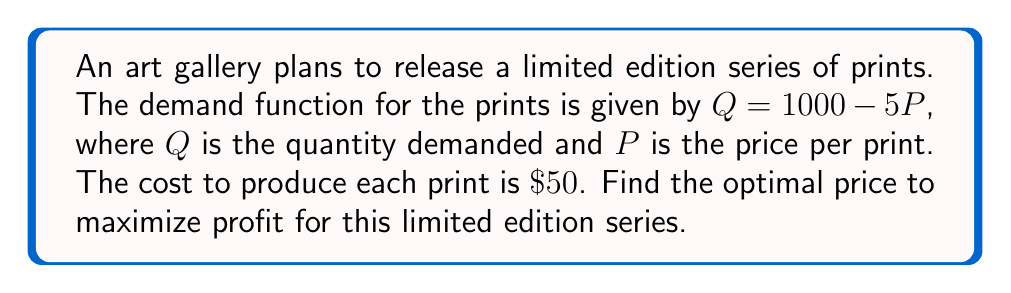Give your solution to this math problem. Let's approach this step-by-step:

1) First, we need to set up the profit function. Profit is revenue minus cost.

2) Revenue function: $R = P \cdot Q = P(1000 - 5P) = 1000P - 5P^2$

3) Cost function: $C = 50Q = 50(1000 - 5P) = 50000 - 250P$

4) Profit function: $\Pi = R - C = (1000P - 5P^2) - (50000 - 250P)$
   $\Pi = 1000P - 5P^2 - 50000 + 250P = 1250P - 5P^2 - 50000$

5) To find the maximum profit, we need to find where the derivative of the profit function equals zero:

   $\frac{d\Pi}{dP} = 1250 - 10P$

6) Set this equal to zero and solve:
   $1250 - 10P = 0$
   $-10P = -1250$
   $P = 125$

7) To confirm this is a maximum, we can check the second derivative:
   $\frac{d^2\Pi}{dP^2} = -10$, which is negative, confirming a maximum.

8) Therefore, the optimal price is $\$125$ per print.
Answer: $\$125$ per print 